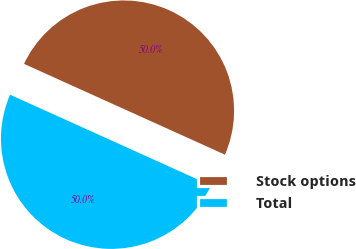<chart> <loc_0><loc_0><loc_500><loc_500><pie_chart><fcel>Stock options<fcel>Total<nl><fcel>50.0%<fcel>50.0%<nl></chart> 